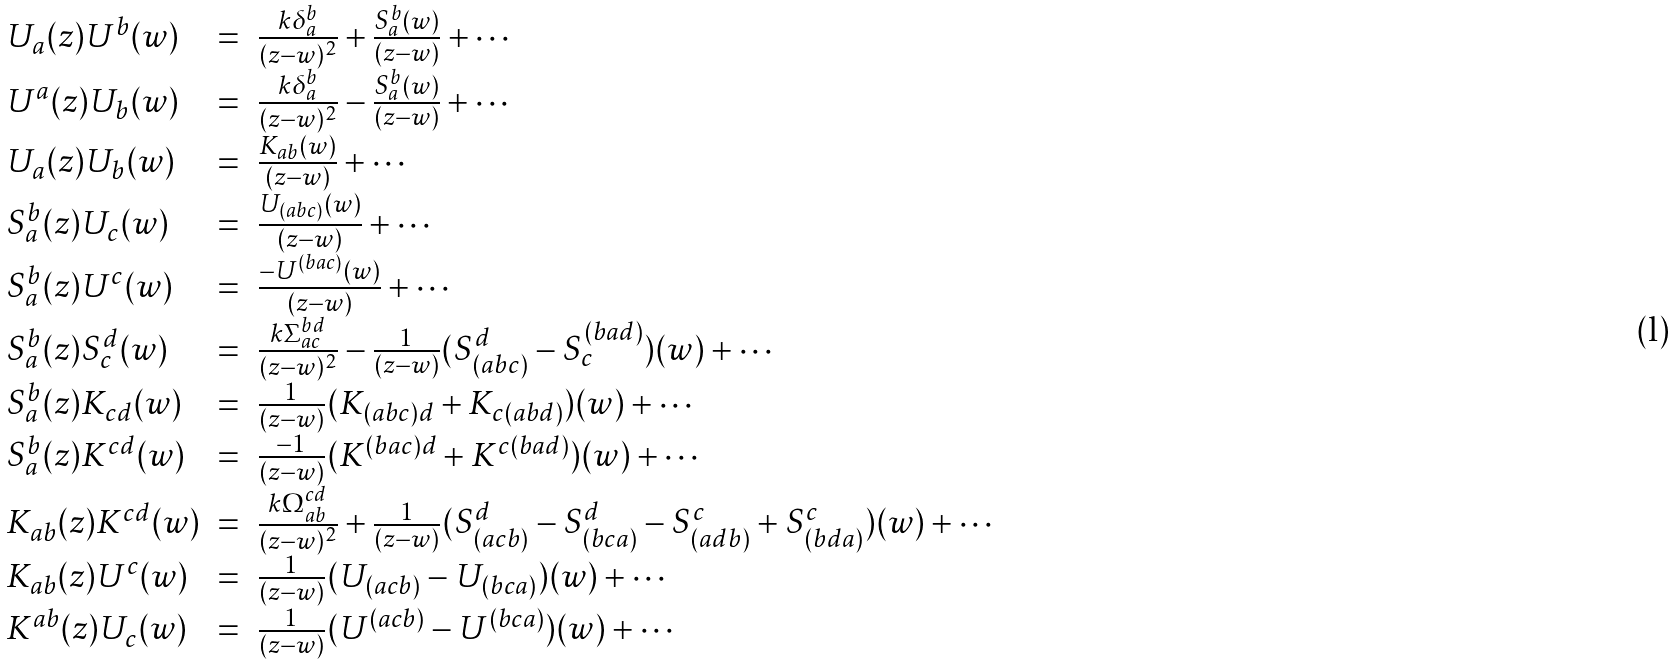<formula> <loc_0><loc_0><loc_500><loc_500>\begin{array} { l l l } U _ { a } ( z ) U ^ { b } ( w ) & = & \frac { k \delta _ { a } ^ { b } } { ( z - w ) ^ { 2 } } + \frac { S _ { a } ^ { b } ( w ) } { ( z - w ) } + \cdots \\ U ^ { a } ( z ) U _ { b } ( w ) & = & \frac { k \delta _ { a } ^ { b } } { ( z - w ) ^ { 2 } } - \frac { S _ { a } ^ { b } ( w ) } { ( z - w ) } + \cdots \\ U _ { a } ( z ) U _ { b } ( w ) & = & \frac { K _ { a b } ( w ) } { ( z - w ) } + \cdots \\ S _ { a } ^ { b } ( z ) U _ { c } ( w ) & = & \frac { U _ { ( a b c ) } ( w ) } { ( z - w ) } + \cdots \\ S _ { a } ^ { b } ( z ) U ^ { c } ( w ) & = & \frac { - U ^ { ( b a c ) } ( w ) } { ( z - w ) } + \cdots \\ S _ { a } ^ { b } ( z ) S _ { c } ^ { d } ( w ) & = & \frac { k \Sigma _ { a c } ^ { b d } } { ( z - w ) ^ { 2 } } - \frac { 1 } { ( z - w ) } ( S _ { ( a b c ) } ^ { d } - S _ { c } ^ { ( b a d ) } ) ( w ) + \cdots \\ S _ { a } ^ { b } ( z ) K _ { c d } ( w ) & = & \frac { 1 } { ( z - w ) } ( K _ { ( a b c ) d } + K _ { c ( a b d ) } ) ( w ) + \cdots \\ S _ { a } ^ { b } ( z ) K ^ { c d } ( w ) & = & \frac { - 1 } { ( z - w ) } ( K ^ { ( b a c ) d } + K ^ { c ( b a d ) } ) ( w ) + \cdots \\ K _ { a b } ( z ) K ^ { c d } ( w ) & = & \frac { k \Omega _ { a b } ^ { c d } } { ( z - w ) ^ { 2 } } + \frac { 1 } { ( z - w ) } ( S _ { ( a c b ) } ^ { d } - S _ { ( b c a ) } ^ { d } - S _ { ( a d b ) } ^ { c } + S _ { ( b d a ) } ^ { c } ) ( w ) + \cdots \\ K _ { a b } ( z ) U ^ { c } ( w ) & = & \frac { 1 } { ( z - w ) } ( U _ { ( a c b ) } - U _ { ( b c a ) } ) ( w ) + \cdots \\ K ^ { a b } ( z ) U _ { c } ( w ) & = & \frac { 1 } { ( z - w ) } ( U ^ { ( a c b ) } - U ^ { ( b c a ) } ) ( w ) + \cdots \end{array}</formula> 